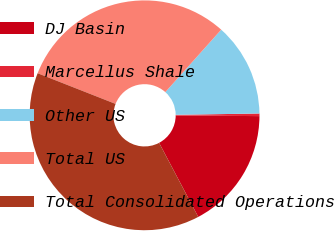<chart> <loc_0><loc_0><loc_500><loc_500><pie_chart><fcel>DJ Basin<fcel>Marcellus Shale<fcel>Other US<fcel>Total US<fcel>Total Consolidated Operations<nl><fcel>17.15%<fcel>0.36%<fcel>13.13%<fcel>30.65%<fcel>38.7%<nl></chart> 